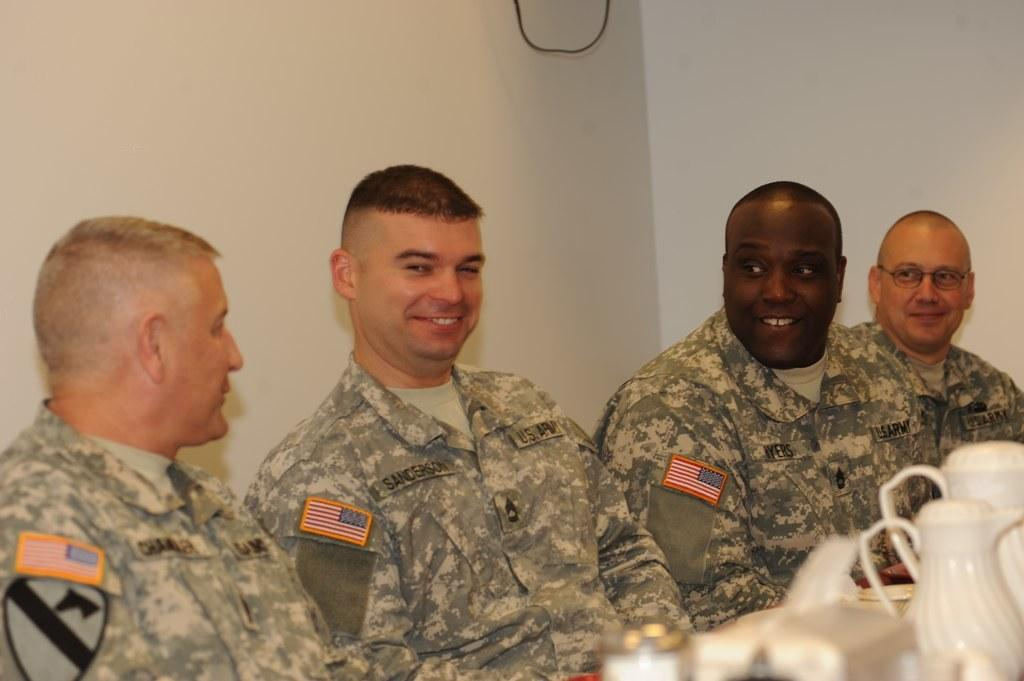What are the men in the image doing? The men are sitting in the image. What is the facial expression of the men? The men are smiling. What objects can be seen in front of the men? There are jars and other objects in front of the men. What can be seen in the background of the image? There is a cable and a wall visible in the background of the image. What time of day is it in the image, considering the presence of a morning bulb? There is no mention of a "morning bulb" in the image, and the time of day cannot be determined from the provided facts. 